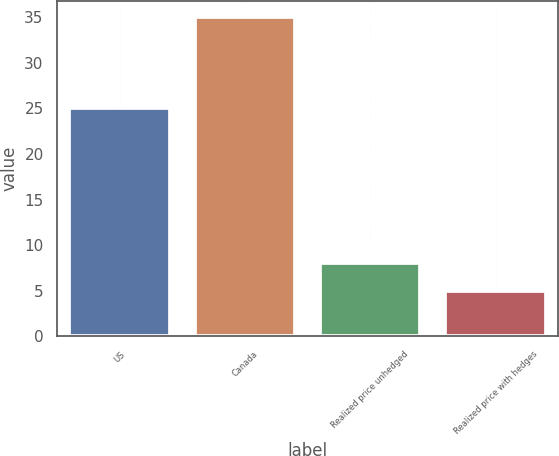<chart> <loc_0><loc_0><loc_500><loc_500><bar_chart><fcel>US<fcel>Canada<fcel>Realized price unhedged<fcel>Realized price with hedges<nl><fcel>25<fcel>35<fcel>8<fcel>5<nl></chart> 